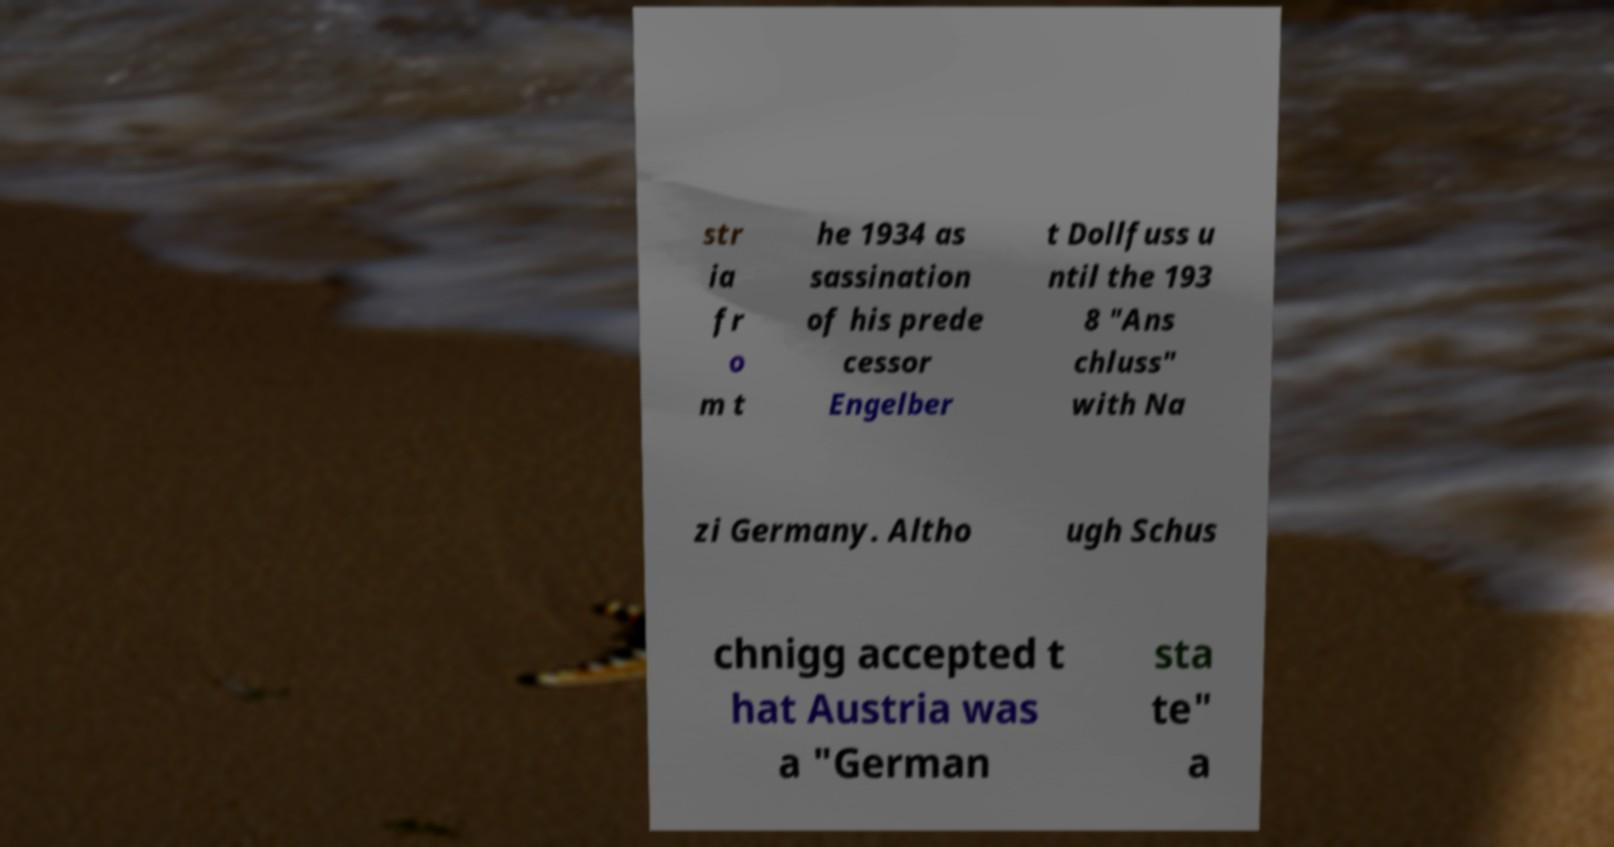Can you accurately transcribe the text from the provided image for me? str ia fr o m t he 1934 as sassination of his prede cessor Engelber t Dollfuss u ntil the 193 8 "Ans chluss" with Na zi Germany. Altho ugh Schus chnigg accepted t hat Austria was a "German sta te" a 